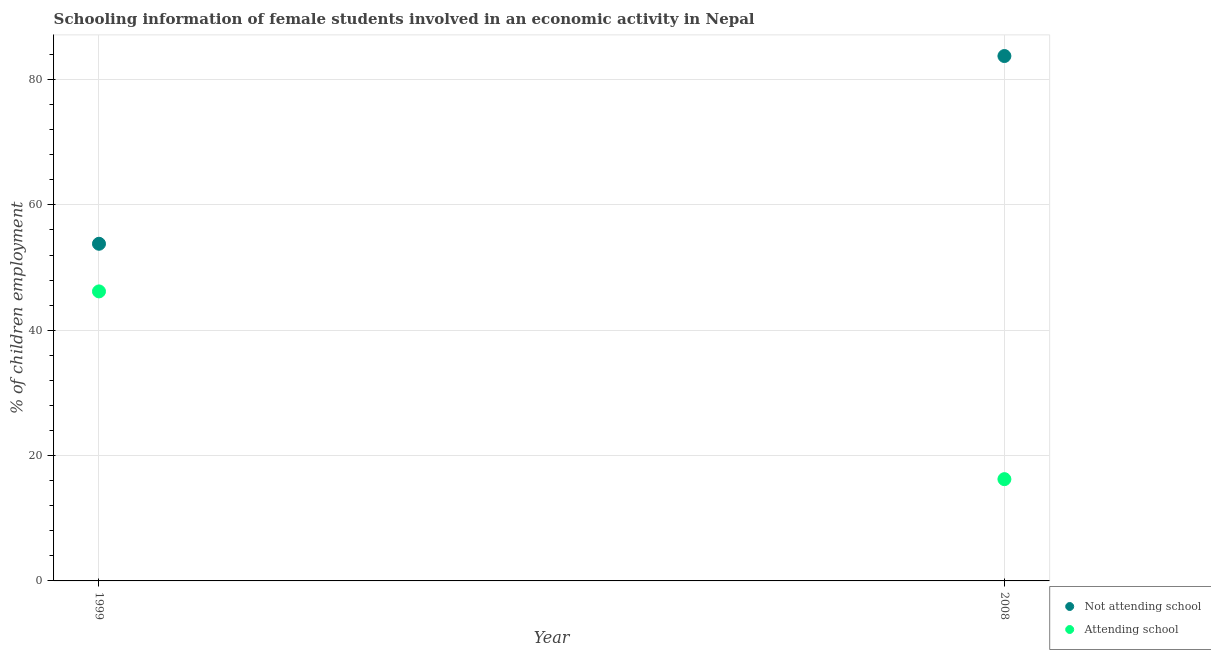Is the number of dotlines equal to the number of legend labels?
Offer a very short reply. Yes. What is the percentage of employed females who are attending school in 1999?
Offer a terse response. 46.2. Across all years, what is the maximum percentage of employed females who are attending school?
Ensure brevity in your answer.  46.2. Across all years, what is the minimum percentage of employed females who are not attending school?
Ensure brevity in your answer.  53.8. What is the total percentage of employed females who are not attending school in the graph?
Your response must be concise. 137.56. What is the difference between the percentage of employed females who are attending school in 1999 and that in 2008?
Make the answer very short. 29.96. What is the difference between the percentage of employed females who are attending school in 1999 and the percentage of employed females who are not attending school in 2008?
Your answer should be very brief. -37.56. What is the average percentage of employed females who are attending school per year?
Offer a very short reply. 31.22. In the year 2008, what is the difference between the percentage of employed females who are attending school and percentage of employed females who are not attending school?
Offer a terse response. -67.52. In how many years, is the percentage of employed females who are attending school greater than 44 %?
Give a very brief answer. 1. What is the ratio of the percentage of employed females who are not attending school in 1999 to that in 2008?
Your answer should be compact. 0.64. Is the percentage of employed females who are not attending school in 1999 less than that in 2008?
Make the answer very short. Yes. Is the percentage of employed females who are attending school strictly greater than the percentage of employed females who are not attending school over the years?
Make the answer very short. No. How many years are there in the graph?
Provide a short and direct response. 2. What is the difference between two consecutive major ticks on the Y-axis?
Your response must be concise. 20. How many legend labels are there?
Provide a short and direct response. 2. What is the title of the graph?
Keep it short and to the point. Schooling information of female students involved in an economic activity in Nepal. Does "Adolescent fertility rate" appear as one of the legend labels in the graph?
Make the answer very short. No. What is the label or title of the Y-axis?
Provide a short and direct response. % of children employment. What is the % of children employment in Not attending school in 1999?
Your answer should be compact. 53.8. What is the % of children employment in Attending school in 1999?
Keep it short and to the point. 46.2. What is the % of children employment in Not attending school in 2008?
Give a very brief answer. 83.76. What is the % of children employment of Attending school in 2008?
Offer a terse response. 16.24. Across all years, what is the maximum % of children employment of Not attending school?
Provide a succinct answer. 83.76. Across all years, what is the maximum % of children employment of Attending school?
Make the answer very short. 46.2. Across all years, what is the minimum % of children employment in Not attending school?
Provide a succinct answer. 53.8. Across all years, what is the minimum % of children employment of Attending school?
Your answer should be compact. 16.24. What is the total % of children employment of Not attending school in the graph?
Ensure brevity in your answer.  137.56. What is the total % of children employment in Attending school in the graph?
Your answer should be very brief. 62.44. What is the difference between the % of children employment in Not attending school in 1999 and that in 2008?
Keep it short and to the point. -29.96. What is the difference between the % of children employment in Attending school in 1999 and that in 2008?
Your answer should be very brief. 29.96. What is the difference between the % of children employment in Not attending school in 1999 and the % of children employment in Attending school in 2008?
Your answer should be very brief. 37.56. What is the average % of children employment of Not attending school per year?
Your answer should be very brief. 68.78. What is the average % of children employment in Attending school per year?
Your answer should be very brief. 31.22. In the year 1999, what is the difference between the % of children employment of Not attending school and % of children employment of Attending school?
Keep it short and to the point. 7.6. In the year 2008, what is the difference between the % of children employment of Not attending school and % of children employment of Attending school?
Your answer should be compact. 67.52. What is the ratio of the % of children employment in Not attending school in 1999 to that in 2008?
Your response must be concise. 0.64. What is the ratio of the % of children employment in Attending school in 1999 to that in 2008?
Your answer should be very brief. 2.84. What is the difference between the highest and the second highest % of children employment of Not attending school?
Provide a succinct answer. 29.96. What is the difference between the highest and the second highest % of children employment in Attending school?
Provide a succinct answer. 29.96. What is the difference between the highest and the lowest % of children employment in Not attending school?
Ensure brevity in your answer.  29.96. What is the difference between the highest and the lowest % of children employment of Attending school?
Offer a terse response. 29.96. 